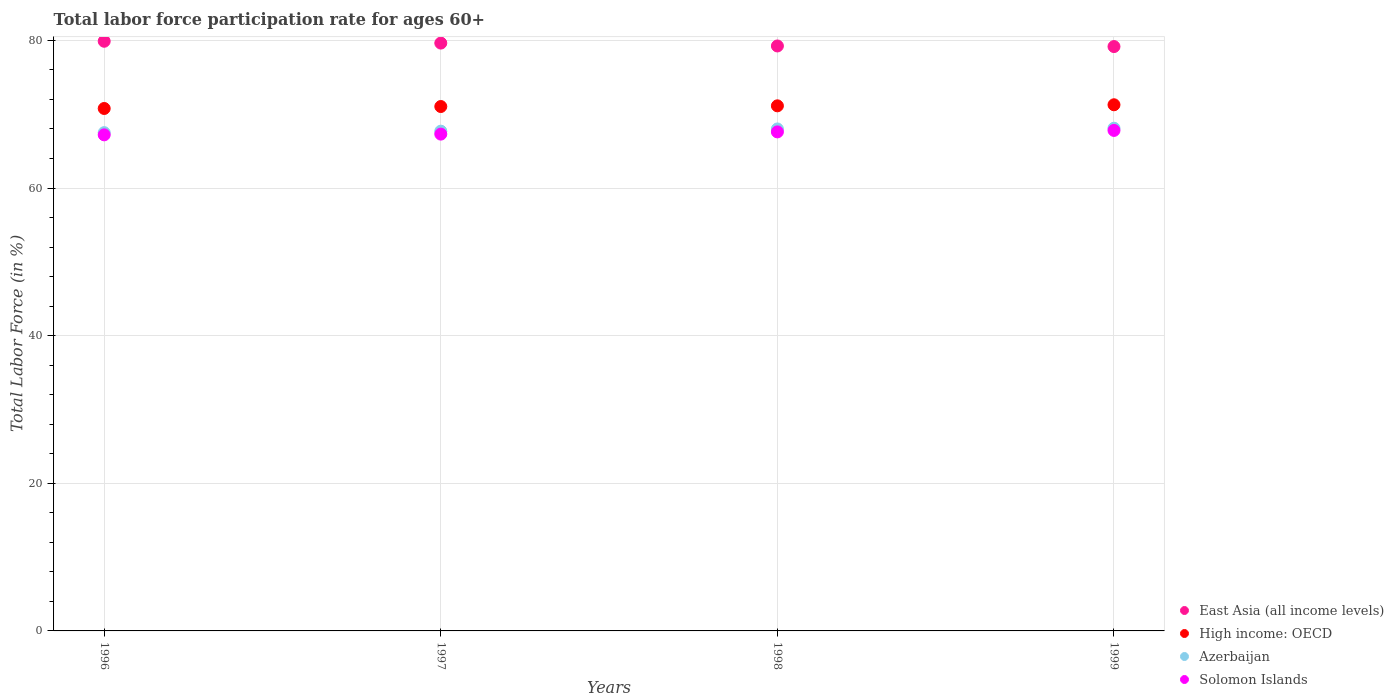What is the labor force participation rate in Azerbaijan in 1996?
Offer a very short reply. 67.5. Across all years, what is the maximum labor force participation rate in Azerbaijan?
Your answer should be compact. 68.1. Across all years, what is the minimum labor force participation rate in East Asia (all income levels)?
Keep it short and to the point. 79.16. In which year was the labor force participation rate in Azerbaijan maximum?
Offer a terse response. 1999. In which year was the labor force participation rate in Azerbaijan minimum?
Your answer should be very brief. 1996. What is the total labor force participation rate in East Asia (all income levels) in the graph?
Give a very brief answer. 317.91. What is the difference between the labor force participation rate in High income: OECD in 1997 and that in 1999?
Make the answer very short. -0.24. What is the difference between the labor force participation rate in Azerbaijan in 1997 and the labor force participation rate in East Asia (all income levels) in 1996?
Provide a succinct answer. -12.18. What is the average labor force participation rate in Azerbaijan per year?
Ensure brevity in your answer.  67.82. In the year 1998, what is the difference between the labor force participation rate in East Asia (all income levels) and labor force participation rate in Solomon Islands?
Ensure brevity in your answer.  11.64. What is the ratio of the labor force participation rate in Azerbaijan in 1996 to that in 1998?
Your answer should be compact. 0.99. Is the difference between the labor force participation rate in East Asia (all income levels) in 1998 and 1999 greater than the difference between the labor force participation rate in Solomon Islands in 1998 and 1999?
Offer a terse response. Yes. What is the difference between the highest and the second highest labor force participation rate in High income: OECD?
Ensure brevity in your answer.  0.14. What is the difference between the highest and the lowest labor force participation rate in High income: OECD?
Provide a short and direct response. 0.5. Is the sum of the labor force participation rate in Solomon Islands in 1997 and 1999 greater than the maximum labor force participation rate in East Asia (all income levels) across all years?
Provide a short and direct response. Yes. Does the labor force participation rate in High income: OECD monotonically increase over the years?
Ensure brevity in your answer.  Yes. Is the labor force participation rate in High income: OECD strictly greater than the labor force participation rate in Azerbaijan over the years?
Provide a short and direct response. Yes. Are the values on the major ticks of Y-axis written in scientific E-notation?
Provide a succinct answer. No. Does the graph contain any zero values?
Offer a very short reply. No. What is the title of the graph?
Your answer should be compact. Total labor force participation rate for ages 60+. What is the label or title of the X-axis?
Your response must be concise. Years. What is the Total Labor Force (in %) in East Asia (all income levels) in 1996?
Ensure brevity in your answer.  79.88. What is the Total Labor Force (in %) in High income: OECD in 1996?
Your answer should be very brief. 70.77. What is the Total Labor Force (in %) in Azerbaijan in 1996?
Your answer should be very brief. 67.5. What is the Total Labor Force (in %) of Solomon Islands in 1996?
Provide a short and direct response. 67.2. What is the Total Labor Force (in %) in East Asia (all income levels) in 1997?
Your response must be concise. 79.63. What is the Total Labor Force (in %) of High income: OECD in 1997?
Provide a short and direct response. 71.04. What is the Total Labor Force (in %) in Azerbaijan in 1997?
Your answer should be very brief. 67.7. What is the Total Labor Force (in %) of Solomon Islands in 1997?
Make the answer very short. 67.3. What is the Total Labor Force (in %) of East Asia (all income levels) in 1998?
Your response must be concise. 79.24. What is the Total Labor Force (in %) of High income: OECD in 1998?
Ensure brevity in your answer.  71.13. What is the Total Labor Force (in %) in Azerbaijan in 1998?
Ensure brevity in your answer.  68. What is the Total Labor Force (in %) in Solomon Islands in 1998?
Ensure brevity in your answer.  67.6. What is the Total Labor Force (in %) in East Asia (all income levels) in 1999?
Ensure brevity in your answer.  79.16. What is the Total Labor Force (in %) of High income: OECD in 1999?
Offer a very short reply. 71.27. What is the Total Labor Force (in %) of Azerbaijan in 1999?
Provide a short and direct response. 68.1. What is the Total Labor Force (in %) of Solomon Islands in 1999?
Provide a succinct answer. 67.8. Across all years, what is the maximum Total Labor Force (in %) of East Asia (all income levels)?
Offer a very short reply. 79.88. Across all years, what is the maximum Total Labor Force (in %) of High income: OECD?
Your response must be concise. 71.27. Across all years, what is the maximum Total Labor Force (in %) in Azerbaijan?
Your response must be concise. 68.1. Across all years, what is the maximum Total Labor Force (in %) in Solomon Islands?
Your answer should be compact. 67.8. Across all years, what is the minimum Total Labor Force (in %) in East Asia (all income levels)?
Make the answer very short. 79.16. Across all years, what is the minimum Total Labor Force (in %) in High income: OECD?
Give a very brief answer. 70.77. Across all years, what is the minimum Total Labor Force (in %) in Azerbaijan?
Offer a very short reply. 67.5. Across all years, what is the minimum Total Labor Force (in %) of Solomon Islands?
Ensure brevity in your answer.  67.2. What is the total Total Labor Force (in %) of East Asia (all income levels) in the graph?
Provide a short and direct response. 317.91. What is the total Total Labor Force (in %) in High income: OECD in the graph?
Your answer should be compact. 284.22. What is the total Total Labor Force (in %) of Azerbaijan in the graph?
Offer a very short reply. 271.3. What is the total Total Labor Force (in %) in Solomon Islands in the graph?
Offer a terse response. 269.9. What is the difference between the Total Labor Force (in %) of East Asia (all income levels) in 1996 and that in 1997?
Your answer should be very brief. 0.25. What is the difference between the Total Labor Force (in %) of High income: OECD in 1996 and that in 1997?
Keep it short and to the point. -0.27. What is the difference between the Total Labor Force (in %) of Solomon Islands in 1996 and that in 1997?
Your answer should be very brief. -0.1. What is the difference between the Total Labor Force (in %) in East Asia (all income levels) in 1996 and that in 1998?
Keep it short and to the point. 0.64. What is the difference between the Total Labor Force (in %) of High income: OECD in 1996 and that in 1998?
Ensure brevity in your answer.  -0.36. What is the difference between the Total Labor Force (in %) of East Asia (all income levels) in 1996 and that in 1999?
Offer a terse response. 0.72. What is the difference between the Total Labor Force (in %) in High income: OECD in 1996 and that in 1999?
Keep it short and to the point. -0.5. What is the difference between the Total Labor Force (in %) in East Asia (all income levels) in 1997 and that in 1998?
Your answer should be compact. 0.39. What is the difference between the Total Labor Force (in %) of High income: OECD in 1997 and that in 1998?
Your response must be concise. -0.09. What is the difference between the Total Labor Force (in %) of Solomon Islands in 1997 and that in 1998?
Make the answer very short. -0.3. What is the difference between the Total Labor Force (in %) of East Asia (all income levels) in 1997 and that in 1999?
Your response must be concise. 0.47. What is the difference between the Total Labor Force (in %) in High income: OECD in 1997 and that in 1999?
Your answer should be compact. -0.24. What is the difference between the Total Labor Force (in %) of Solomon Islands in 1997 and that in 1999?
Make the answer very short. -0.5. What is the difference between the Total Labor Force (in %) of East Asia (all income levels) in 1998 and that in 1999?
Give a very brief answer. 0.08. What is the difference between the Total Labor Force (in %) in High income: OECD in 1998 and that in 1999?
Offer a terse response. -0.14. What is the difference between the Total Labor Force (in %) in East Asia (all income levels) in 1996 and the Total Labor Force (in %) in High income: OECD in 1997?
Provide a short and direct response. 8.84. What is the difference between the Total Labor Force (in %) in East Asia (all income levels) in 1996 and the Total Labor Force (in %) in Azerbaijan in 1997?
Your response must be concise. 12.18. What is the difference between the Total Labor Force (in %) of East Asia (all income levels) in 1996 and the Total Labor Force (in %) of Solomon Islands in 1997?
Your response must be concise. 12.58. What is the difference between the Total Labor Force (in %) of High income: OECD in 1996 and the Total Labor Force (in %) of Azerbaijan in 1997?
Offer a very short reply. 3.07. What is the difference between the Total Labor Force (in %) of High income: OECD in 1996 and the Total Labor Force (in %) of Solomon Islands in 1997?
Your response must be concise. 3.47. What is the difference between the Total Labor Force (in %) of Azerbaijan in 1996 and the Total Labor Force (in %) of Solomon Islands in 1997?
Make the answer very short. 0.2. What is the difference between the Total Labor Force (in %) of East Asia (all income levels) in 1996 and the Total Labor Force (in %) of High income: OECD in 1998?
Keep it short and to the point. 8.75. What is the difference between the Total Labor Force (in %) in East Asia (all income levels) in 1996 and the Total Labor Force (in %) in Azerbaijan in 1998?
Offer a very short reply. 11.88. What is the difference between the Total Labor Force (in %) in East Asia (all income levels) in 1996 and the Total Labor Force (in %) in Solomon Islands in 1998?
Give a very brief answer. 12.28. What is the difference between the Total Labor Force (in %) in High income: OECD in 1996 and the Total Labor Force (in %) in Azerbaijan in 1998?
Provide a succinct answer. 2.77. What is the difference between the Total Labor Force (in %) of High income: OECD in 1996 and the Total Labor Force (in %) of Solomon Islands in 1998?
Offer a very short reply. 3.17. What is the difference between the Total Labor Force (in %) in East Asia (all income levels) in 1996 and the Total Labor Force (in %) in High income: OECD in 1999?
Your answer should be compact. 8.6. What is the difference between the Total Labor Force (in %) in East Asia (all income levels) in 1996 and the Total Labor Force (in %) in Azerbaijan in 1999?
Provide a short and direct response. 11.78. What is the difference between the Total Labor Force (in %) of East Asia (all income levels) in 1996 and the Total Labor Force (in %) of Solomon Islands in 1999?
Ensure brevity in your answer.  12.08. What is the difference between the Total Labor Force (in %) of High income: OECD in 1996 and the Total Labor Force (in %) of Azerbaijan in 1999?
Keep it short and to the point. 2.67. What is the difference between the Total Labor Force (in %) of High income: OECD in 1996 and the Total Labor Force (in %) of Solomon Islands in 1999?
Keep it short and to the point. 2.97. What is the difference between the Total Labor Force (in %) of East Asia (all income levels) in 1997 and the Total Labor Force (in %) of High income: OECD in 1998?
Your answer should be very brief. 8.5. What is the difference between the Total Labor Force (in %) in East Asia (all income levels) in 1997 and the Total Labor Force (in %) in Azerbaijan in 1998?
Offer a very short reply. 11.63. What is the difference between the Total Labor Force (in %) in East Asia (all income levels) in 1997 and the Total Labor Force (in %) in Solomon Islands in 1998?
Provide a short and direct response. 12.03. What is the difference between the Total Labor Force (in %) of High income: OECD in 1997 and the Total Labor Force (in %) of Azerbaijan in 1998?
Make the answer very short. 3.04. What is the difference between the Total Labor Force (in %) in High income: OECD in 1997 and the Total Labor Force (in %) in Solomon Islands in 1998?
Your answer should be very brief. 3.44. What is the difference between the Total Labor Force (in %) in East Asia (all income levels) in 1997 and the Total Labor Force (in %) in High income: OECD in 1999?
Ensure brevity in your answer.  8.36. What is the difference between the Total Labor Force (in %) of East Asia (all income levels) in 1997 and the Total Labor Force (in %) of Azerbaijan in 1999?
Keep it short and to the point. 11.53. What is the difference between the Total Labor Force (in %) in East Asia (all income levels) in 1997 and the Total Labor Force (in %) in Solomon Islands in 1999?
Ensure brevity in your answer.  11.83. What is the difference between the Total Labor Force (in %) of High income: OECD in 1997 and the Total Labor Force (in %) of Azerbaijan in 1999?
Make the answer very short. 2.94. What is the difference between the Total Labor Force (in %) in High income: OECD in 1997 and the Total Labor Force (in %) in Solomon Islands in 1999?
Your answer should be very brief. 3.24. What is the difference between the Total Labor Force (in %) of Azerbaijan in 1997 and the Total Labor Force (in %) of Solomon Islands in 1999?
Your response must be concise. -0.1. What is the difference between the Total Labor Force (in %) of East Asia (all income levels) in 1998 and the Total Labor Force (in %) of High income: OECD in 1999?
Make the answer very short. 7.97. What is the difference between the Total Labor Force (in %) of East Asia (all income levels) in 1998 and the Total Labor Force (in %) of Azerbaijan in 1999?
Offer a terse response. 11.14. What is the difference between the Total Labor Force (in %) in East Asia (all income levels) in 1998 and the Total Labor Force (in %) in Solomon Islands in 1999?
Provide a short and direct response. 11.44. What is the difference between the Total Labor Force (in %) in High income: OECD in 1998 and the Total Labor Force (in %) in Azerbaijan in 1999?
Make the answer very short. 3.03. What is the difference between the Total Labor Force (in %) in High income: OECD in 1998 and the Total Labor Force (in %) in Solomon Islands in 1999?
Make the answer very short. 3.33. What is the average Total Labor Force (in %) in East Asia (all income levels) per year?
Provide a short and direct response. 79.48. What is the average Total Labor Force (in %) in High income: OECD per year?
Provide a succinct answer. 71.05. What is the average Total Labor Force (in %) in Azerbaijan per year?
Offer a terse response. 67.83. What is the average Total Labor Force (in %) of Solomon Islands per year?
Ensure brevity in your answer.  67.47. In the year 1996, what is the difference between the Total Labor Force (in %) in East Asia (all income levels) and Total Labor Force (in %) in High income: OECD?
Your answer should be compact. 9.11. In the year 1996, what is the difference between the Total Labor Force (in %) of East Asia (all income levels) and Total Labor Force (in %) of Azerbaijan?
Offer a very short reply. 12.38. In the year 1996, what is the difference between the Total Labor Force (in %) of East Asia (all income levels) and Total Labor Force (in %) of Solomon Islands?
Make the answer very short. 12.68. In the year 1996, what is the difference between the Total Labor Force (in %) in High income: OECD and Total Labor Force (in %) in Azerbaijan?
Your answer should be compact. 3.27. In the year 1996, what is the difference between the Total Labor Force (in %) in High income: OECD and Total Labor Force (in %) in Solomon Islands?
Keep it short and to the point. 3.57. In the year 1997, what is the difference between the Total Labor Force (in %) in East Asia (all income levels) and Total Labor Force (in %) in High income: OECD?
Your answer should be compact. 8.59. In the year 1997, what is the difference between the Total Labor Force (in %) of East Asia (all income levels) and Total Labor Force (in %) of Azerbaijan?
Your answer should be very brief. 11.93. In the year 1997, what is the difference between the Total Labor Force (in %) in East Asia (all income levels) and Total Labor Force (in %) in Solomon Islands?
Offer a terse response. 12.33. In the year 1997, what is the difference between the Total Labor Force (in %) of High income: OECD and Total Labor Force (in %) of Azerbaijan?
Your response must be concise. 3.34. In the year 1997, what is the difference between the Total Labor Force (in %) of High income: OECD and Total Labor Force (in %) of Solomon Islands?
Give a very brief answer. 3.74. In the year 1997, what is the difference between the Total Labor Force (in %) of Azerbaijan and Total Labor Force (in %) of Solomon Islands?
Keep it short and to the point. 0.4. In the year 1998, what is the difference between the Total Labor Force (in %) in East Asia (all income levels) and Total Labor Force (in %) in High income: OECD?
Provide a succinct answer. 8.11. In the year 1998, what is the difference between the Total Labor Force (in %) of East Asia (all income levels) and Total Labor Force (in %) of Azerbaijan?
Offer a very short reply. 11.24. In the year 1998, what is the difference between the Total Labor Force (in %) in East Asia (all income levels) and Total Labor Force (in %) in Solomon Islands?
Make the answer very short. 11.64. In the year 1998, what is the difference between the Total Labor Force (in %) of High income: OECD and Total Labor Force (in %) of Azerbaijan?
Offer a very short reply. 3.13. In the year 1998, what is the difference between the Total Labor Force (in %) in High income: OECD and Total Labor Force (in %) in Solomon Islands?
Give a very brief answer. 3.53. In the year 1999, what is the difference between the Total Labor Force (in %) in East Asia (all income levels) and Total Labor Force (in %) in High income: OECD?
Provide a succinct answer. 7.89. In the year 1999, what is the difference between the Total Labor Force (in %) in East Asia (all income levels) and Total Labor Force (in %) in Azerbaijan?
Make the answer very short. 11.06. In the year 1999, what is the difference between the Total Labor Force (in %) of East Asia (all income levels) and Total Labor Force (in %) of Solomon Islands?
Make the answer very short. 11.36. In the year 1999, what is the difference between the Total Labor Force (in %) of High income: OECD and Total Labor Force (in %) of Azerbaijan?
Provide a short and direct response. 3.17. In the year 1999, what is the difference between the Total Labor Force (in %) of High income: OECD and Total Labor Force (in %) of Solomon Islands?
Offer a terse response. 3.47. What is the ratio of the Total Labor Force (in %) of East Asia (all income levels) in 1996 to that in 1997?
Provide a short and direct response. 1. What is the ratio of the Total Labor Force (in %) of High income: OECD in 1996 to that in 1997?
Give a very brief answer. 1. What is the ratio of the Total Labor Force (in %) in Azerbaijan in 1996 to that in 1997?
Ensure brevity in your answer.  1. What is the ratio of the Total Labor Force (in %) in East Asia (all income levels) in 1996 to that in 1998?
Offer a terse response. 1.01. What is the ratio of the Total Labor Force (in %) in High income: OECD in 1996 to that in 1998?
Your response must be concise. 0.99. What is the ratio of the Total Labor Force (in %) of Solomon Islands in 1996 to that in 1998?
Your response must be concise. 0.99. What is the ratio of the Total Labor Force (in %) in East Asia (all income levels) in 1996 to that in 1999?
Your response must be concise. 1.01. What is the ratio of the Total Labor Force (in %) of Solomon Islands in 1996 to that in 1999?
Offer a terse response. 0.99. What is the ratio of the Total Labor Force (in %) in East Asia (all income levels) in 1997 to that in 1998?
Provide a short and direct response. 1. What is the ratio of the Total Labor Force (in %) of High income: OECD in 1997 to that in 1998?
Provide a succinct answer. 1. What is the ratio of the Total Labor Force (in %) in East Asia (all income levels) in 1997 to that in 1999?
Keep it short and to the point. 1.01. What is the ratio of the Total Labor Force (in %) of High income: OECD in 1997 to that in 1999?
Ensure brevity in your answer.  1. What is the ratio of the Total Labor Force (in %) in East Asia (all income levels) in 1998 to that in 1999?
Make the answer very short. 1. What is the ratio of the Total Labor Force (in %) in High income: OECD in 1998 to that in 1999?
Your answer should be compact. 1. What is the ratio of the Total Labor Force (in %) of Solomon Islands in 1998 to that in 1999?
Provide a short and direct response. 1. What is the difference between the highest and the second highest Total Labor Force (in %) in East Asia (all income levels)?
Offer a very short reply. 0.25. What is the difference between the highest and the second highest Total Labor Force (in %) of High income: OECD?
Give a very brief answer. 0.14. What is the difference between the highest and the lowest Total Labor Force (in %) in East Asia (all income levels)?
Ensure brevity in your answer.  0.72. What is the difference between the highest and the lowest Total Labor Force (in %) of High income: OECD?
Your answer should be compact. 0.5. What is the difference between the highest and the lowest Total Labor Force (in %) in Azerbaijan?
Offer a terse response. 0.6. What is the difference between the highest and the lowest Total Labor Force (in %) in Solomon Islands?
Your response must be concise. 0.6. 